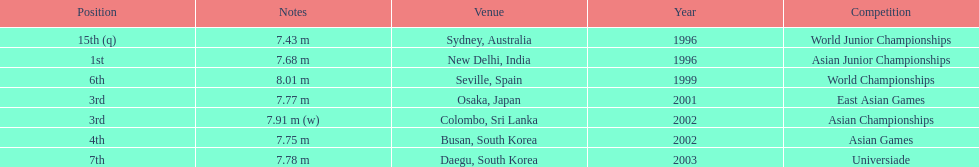In what year was the position of 3rd first achieved? 2001. 